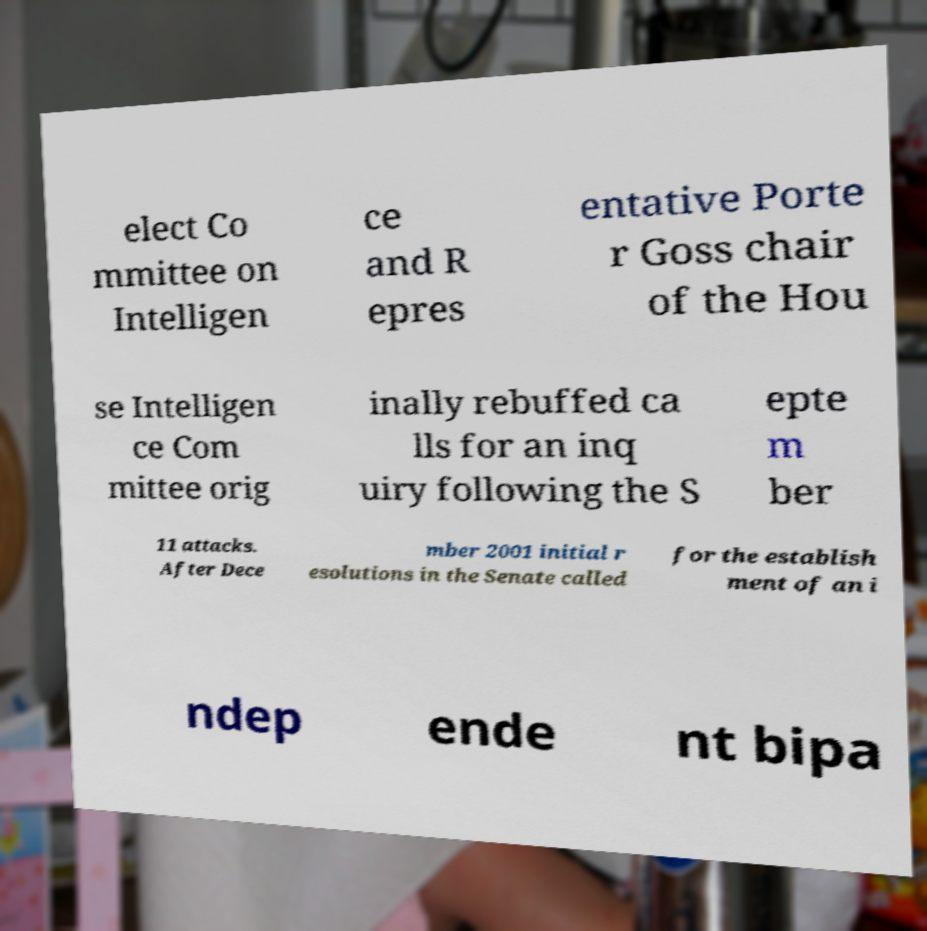For documentation purposes, I need the text within this image transcribed. Could you provide that? elect Co mmittee on Intelligen ce and R epres entative Porte r Goss chair of the Hou se Intelligen ce Com mittee orig inally rebuffed ca lls for an inq uiry following the S epte m ber 11 attacks. After Dece mber 2001 initial r esolutions in the Senate called for the establish ment of an i ndep ende nt bipa 